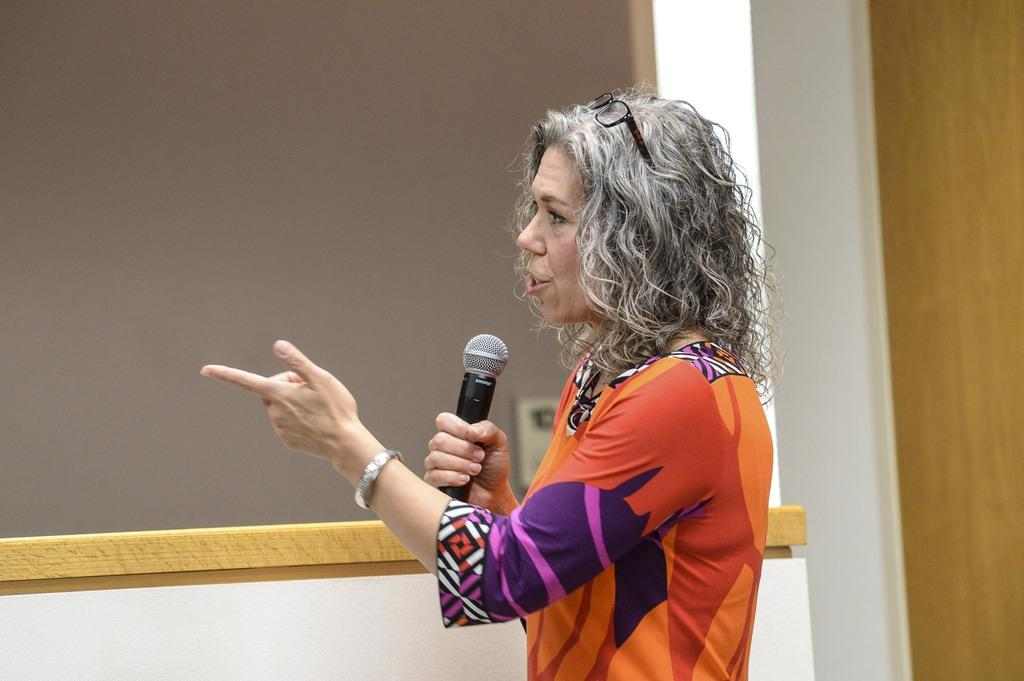Who is the main subject in the image? There is a woman in the image. What is the woman doing in the image? The woman is talking on a microphone. What can be seen in the background of the image? There is a wall in the background of the image. What type of metal is used to make the cart in the image? There is no cart present in the image, so it is not possible to determine what type of metal might be used. 